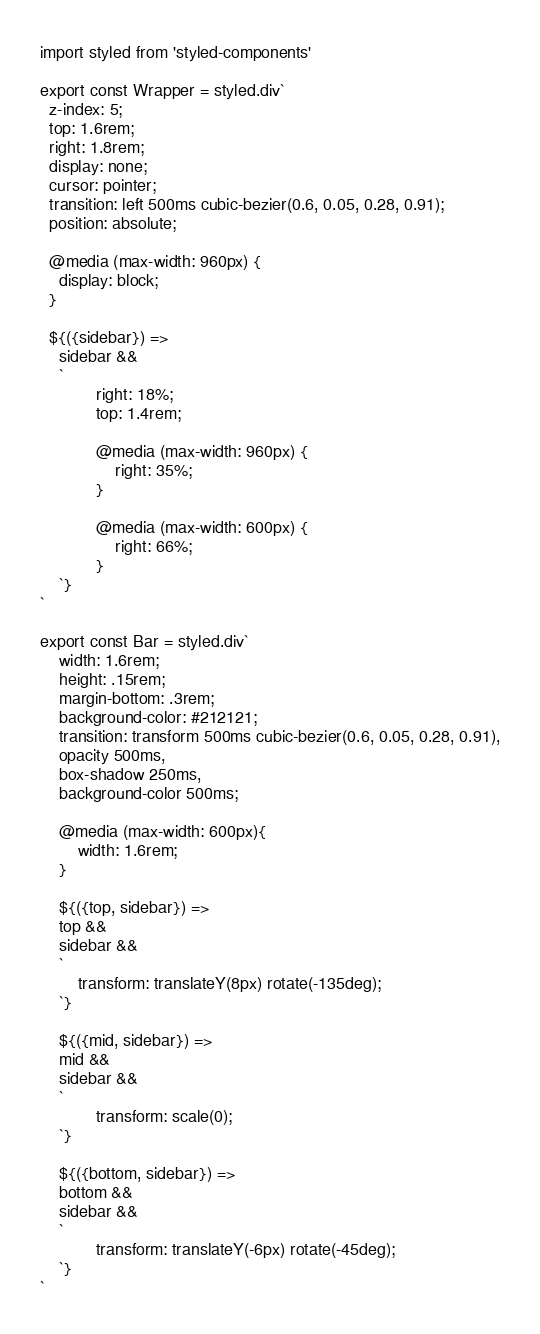<code> <loc_0><loc_0><loc_500><loc_500><_JavaScript_>import styled from 'styled-components'

export const Wrapper = styled.div`
  z-index: 5;
  top: 1.6rem;
  right: 1.8rem;
  display: none;
  cursor: pointer;
  transition: left 500ms cubic-bezier(0.6, 0.05, 0.28, 0.91);
  position: absolute;

  @media (max-width: 960px) {
    display: block;
  }

  ${({sidebar}) =>
    sidebar &&
    `
			right: 18%;
			top: 1.4rem;
		
			@media (max-width: 960px) {
				right: 35%;
			}
		
			@media (max-width: 600px) {
				right: 66%;
			}
	`}
`

export const Bar = styled.div`
	width: 1.6rem;
	height: .15rem;
	margin-bottom: .3rem;
	background-color: #212121;
	transition: transform 500ms cubic-bezier(0.6, 0.05, 0.28, 0.91),
	opacity 500ms,
	box-shadow 250ms,
	background-color 500ms;

	@media (max-width: 600px){
		width: 1.6rem;
	}

	${({top, sidebar}) =>
    top &&
    sidebar &&
    `
		transform: translateY(8px) rotate(-135deg);
	`}

	${({mid, sidebar}) =>
    mid &&
    sidebar &&
    `
			transform: scale(0);
	`}

	${({bottom, sidebar}) =>
    bottom &&
    sidebar &&
    `
			transform: translateY(-6px) rotate(-45deg);
	`}
`
</code> 